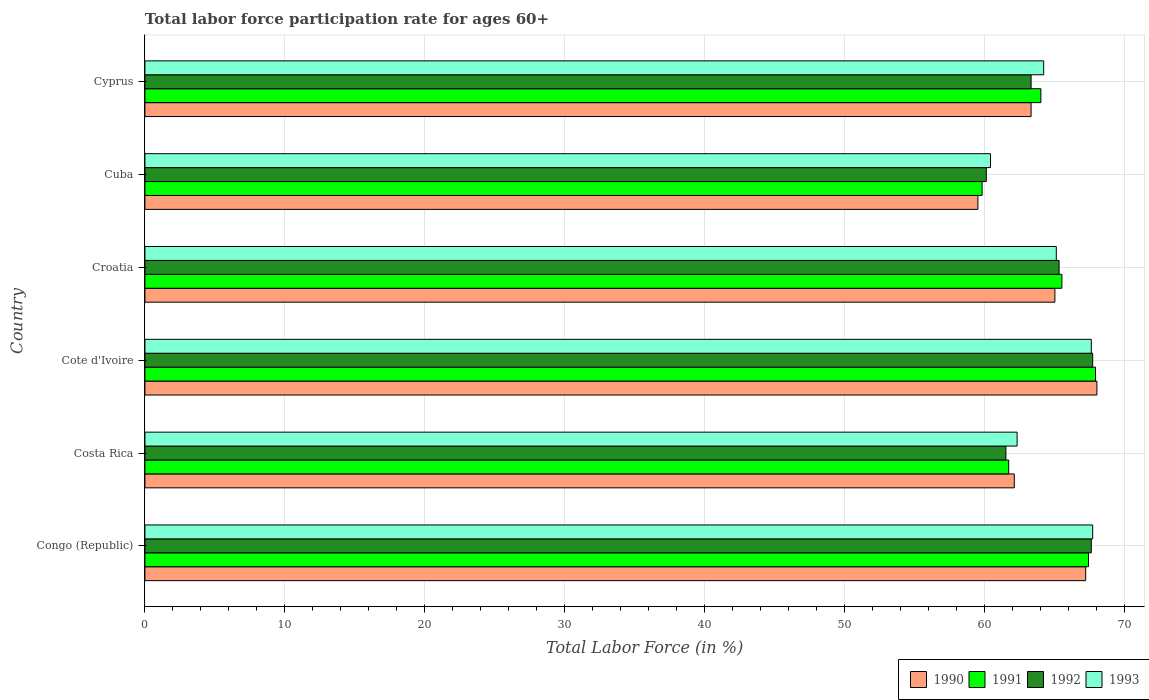How many groups of bars are there?
Your answer should be very brief. 6. Are the number of bars on each tick of the Y-axis equal?
Offer a very short reply. Yes. How many bars are there on the 5th tick from the top?
Provide a succinct answer. 4. How many bars are there on the 6th tick from the bottom?
Provide a short and direct response. 4. What is the label of the 4th group of bars from the top?
Give a very brief answer. Cote d'Ivoire. What is the labor force participation rate in 1993 in Cyprus?
Your response must be concise. 64.2. Across all countries, what is the maximum labor force participation rate in 1992?
Your answer should be compact. 67.7. Across all countries, what is the minimum labor force participation rate in 1990?
Provide a short and direct response. 59.5. In which country was the labor force participation rate in 1991 maximum?
Make the answer very short. Cote d'Ivoire. In which country was the labor force participation rate in 1992 minimum?
Give a very brief answer. Cuba. What is the total labor force participation rate in 1991 in the graph?
Provide a succinct answer. 386.3. What is the difference between the labor force participation rate in 1990 in Costa Rica and that in Cyprus?
Provide a short and direct response. -1.2. What is the difference between the labor force participation rate in 1990 in Croatia and the labor force participation rate in 1992 in Congo (Republic)?
Offer a very short reply. -2.6. What is the average labor force participation rate in 1993 per country?
Ensure brevity in your answer.  64.55. What is the difference between the labor force participation rate in 1991 and labor force participation rate in 1990 in Cuba?
Provide a short and direct response. 0.3. What is the ratio of the labor force participation rate in 1993 in Congo (Republic) to that in Cuba?
Your response must be concise. 1.12. Is the labor force participation rate in 1991 in Congo (Republic) less than that in Cote d'Ivoire?
Offer a very short reply. Yes. What is the difference between the highest and the lowest labor force participation rate in 1992?
Provide a short and direct response. 7.6. What does the 3rd bar from the top in Cote d'Ivoire represents?
Offer a terse response. 1991. Is it the case that in every country, the sum of the labor force participation rate in 1992 and labor force participation rate in 1993 is greater than the labor force participation rate in 1991?
Offer a terse response. Yes. Are all the bars in the graph horizontal?
Give a very brief answer. Yes. What is the difference between two consecutive major ticks on the X-axis?
Make the answer very short. 10. Are the values on the major ticks of X-axis written in scientific E-notation?
Your answer should be compact. No. Does the graph contain grids?
Your answer should be very brief. Yes. Where does the legend appear in the graph?
Your response must be concise. Bottom right. What is the title of the graph?
Make the answer very short. Total labor force participation rate for ages 60+. Does "2012" appear as one of the legend labels in the graph?
Offer a very short reply. No. What is the label or title of the X-axis?
Offer a very short reply. Total Labor Force (in %). What is the label or title of the Y-axis?
Your response must be concise. Country. What is the Total Labor Force (in %) of 1990 in Congo (Republic)?
Keep it short and to the point. 67.2. What is the Total Labor Force (in %) in 1991 in Congo (Republic)?
Make the answer very short. 67.4. What is the Total Labor Force (in %) in 1992 in Congo (Republic)?
Ensure brevity in your answer.  67.6. What is the Total Labor Force (in %) in 1993 in Congo (Republic)?
Offer a very short reply. 67.7. What is the Total Labor Force (in %) of 1990 in Costa Rica?
Your response must be concise. 62.1. What is the Total Labor Force (in %) of 1991 in Costa Rica?
Provide a succinct answer. 61.7. What is the Total Labor Force (in %) of 1992 in Costa Rica?
Keep it short and to the point. 61.5. What is the Total Labor Force (in %) of 1993 in Costa Rica?
Make the answer very short. 62.3. What is the Total Labor Force (in %) in 1990 in Cote d'Ivoire?
Your answer should be very brief. 68. What is the Total Labor Force (in %) in 1991 in Cote d'Ivoire?
Your answer should be very brief. 67.9. What is the Total Labor Force (in %) of 1992 in Cote d'Ivoire?
Your answer should be very brief. 67.7. What is the Total Labor Force (in %) in 1993 in Cote d'Ivoire?
Provide a short and direct response. 67.6. What is the Total Labor Force (in %) of 1990 in Croatia?
Give a very brief answer. 65. What is the Total Labor Force (in %) of 1991 in Croatia?
Your answer should be compact. 65.5. What is the Total Labor Force (in %) in 1992 in Croatia?
Provide a short and direct response. 65.3. What is the Total Labor Force (in %) of 1993 in Croatia?
Offer a very short reply. 65.1. What is the Total Labor Force (in %) in 1990 in Cuba?
Provide a short and direct response. 59.5. What is the Total Labor Force (in %) of 1991 in Cuba?
Offer a terse response. 59.8. What is the Total Labor Force (in %) in 1992 in Cuba?
Provide a succinct answer. 60.1. What is the Total Labor Force (in %) of 1993 in Cuba?
Your response must be concise. 60.4. What is the Total Labor Force (in %) in 1990 in Cyprus?
Offer a very short reply. 63.3. What is the Total Labor Force (in %) of 1992 in Cyprus?
Make the answer very short. 63.3. What is the Total Labor Force (in %) of 1993 in Cyprus?
Provide a short and direct response. 64.2. Across all countries, what is the maximum Total Labor Force (in %) of 1990?
Give a very brief answer. 68. Across all countries, what is the maximum Total Labor Force (in %) in 1991?
Offer a very short reply. 67.9. Across all countries, what is the maximum Total Labor Force (in %) of 1992?
Your answer should be very brief. 67.7. Across all countries, what is the maximum Total Labor Force (in %) of 1993?
Offer a very short reply. 67.7. Across all countries, what is the minimum Total Labor Force (in %) in 1990?
Keep it short and to the point. 59.5. Across all countries, what is the minimum Total Labor Force (in %) in 1991?
Ensure brevity in your answer.  59.8. Across all countries, what is the minimum Total Labor Force (in %) of 1992?
Offer a terse response. 60.1. Across all countries, what is the minimum Total Labor Force (in %) of 1993?
Give a very brief answer. 60.4. What is the total Total Labor Force (in %) of 1990 in the graph?
Provide a short and direct response. 385.1. What is the total Total Labor Force (in %) in 1991 in the graph?
Give a very brief answer. 386.3. What is the total Total Labor Force (in %) in 1992 in the graph?
Provide a short and direct response. 385.5. What is the total Total Labor Force (in %) in 1993 in the graph?
Ensure brevity in your answer.  387.3. What is the difference between the Total Labor Force (in %) of 1992 in Congo (Republic) and that in Costa Rica?
Your answer should be very brief. 6.1. What is the difference between the Total Labor Force (in %) in 1992 in Congo (Republic) and that in Cote d'Ivoire?
Ensure brevity in your answer.  -0.1. What is the difference between the Total Labor Force (in %) of 1993 in Congo (Republic) and that in Cote d'Ivoire?
Your answer should be compact. 0.1. What is the difference between the Total Labor Force (in %) of 1990 in Congo (Republic) and that in Croatia?
Ensure brevity in your answer.  2.2. What is the difference between the Total Labor Force (in %) of 1993 in Congo (Republic) and that in Croatia?
Provide a short and direct response. 2.6. What is the difference between the Total Labor Force (in %) in 1991 in Congo (Republic) and that in Cuba?
Give a very brief answer. 7.6. What is the difference between the Total Labor Force (in %) in 1990 in Congo (Republic) and that in Cyprus?
Ensure brevity in your answer.  3.9. What is the difference between the Total Labor Force (in %) of 1991 in Congo (Republic) and that in Cyprus?
Your answer should be compact. 3.4. What is the difference between the Total Labor Force (in %) in 1992 in Congo (Republic) and that in Cyprus?
Your answer should be very brief. 4.3. What is the difference between the Total Labor Force (in %) in 1991 in Costa Rica and that in Cote d'Ivoire?
Make the answer very short. -6.2. What is the difference between the Total Labor Force (in %) of 1990 in Costa Rica and that in Croatia?
Your response must be concise. -2.9. What is the difference between the Total Labor Force (in %) of 1991 in Costa Rica and that in Croatia?
Make the answer very short. -3.8. What is the difference between the Total Labor Force (in %) in 1992 in Costa Rica and that in Croatia?
Your answer should be compact. -3.8. What is the difference between the Total Labor Force (in %) in 1990 in Costa Rica and that in Cuba?
Offer a very short reply. 2.6. What is the difference between the Total Labor Force (in %) of 1991 in Costa Rica and that in Cuba?
Offer a terse response. 1.9. What is the difference between the Total Labor Force (in %) of 1990 in Costa Rica and that in Cyprus?
Provide a succinct answer. -1.2. What is the difference between the Total Labor Force (in %) in 1991 in Costa Rica and that in Cyprus?
Your answer should be very brief. -2.3. What is the difference between the Total Labor Force (in %) in 1992 in Costa Rica and that in Cyprus?
Provide a succinct answer. -1.8. What is the difference between the Total Labor Force (in %) of 1993 in Costa Rica and that in Cyprus?
Provide a succinct answer. -1.9. What is the difference between the Total Labor Force (in %) in 1991 in Cote d'Ivoire and that in Croatia?
Your answer should be very brief. 2.4. What is the difference between the Total Labor Force (in %) of 1993 in Cote d'Ivoire and that in Croatia?
Your answer should be very brief. 2.5. What is the difference between the Total Labor Force (in %) of 1990 in Cote d'Ivoire and that in Cuba?
Your answer should be compact. 8.5. What is the difference between the Total Labor Force (in %) of 1991 in Cote d'Ivoire and that in Cuba?
Make the answer very short. 8.1. What is the difference between the Total Labor Force (in %) in 1992 in Cote d'Ivoire and that in Cuba?
Give a very brief answer. 7.6. What is the difference between the Total Labor Force (in %) in 1990 in Cote d'Ivoire and that in Cyprus?
Offer a terse response. 4.7. What is the difference between the Total Labor Force (in %) of 1991 in Cote d'Ivoire and that in Cyprus?
Offer a terse response. 3.9. What is the difference between the Total Labor Force (in %) in 1993 in Cote d'Ivoire and that in Cyprus?
Keep it short and to the point. 3.4. What is the difference between the Total Labor Force (in %) of 1990 in Croatia and that in Cuba?
Your answer should be compact. 5.5. What is the difference between the Total Labor Force (in %) of 1992 in Croatia and that in Cuba?
Offer a terse response. 5.2. What is the difference between the Total Labor Force (in %) in 1990 in Croatia and that in Cyprus?
Your answer should be very brief. 1.7. What is the difference between the Total Labor Force (in %) in 1990 in Cuba and that in Cyprus?
Your answer should be very brief. -3.8. What is the difference between the Total Labor Force (in %) in 1991 in Cuba and that in Cyprus?
Your response must be concise. -4.2. What is the difference between the Total Labor Force (in %) of 1992 in Cuba and that in Cyprus?
Provide a short and direct response. -3.2. What is the difference between the Total Labor Force (in %) of 1993 in Cuba and that in Cyprus?
Your answer should be compact. -3.8. What is the difference between the Total Labor Force (in %) in 1990 in Congo (Republic) and the Total Labor Force (in %) in 1991 in Costa Rica?
Give a very brief answer. 5.5. What is the difference between the Total Labor Force (in %) in 1990 in Congo (Republic) and the Total Labor Force (in %) in 1992 in Costa Rica?
Ensure brevity in your answer.  5.7. What is the difference between the Total Labor Force (in %) in 1991 in Congo (Republic) and the Total Labor Force (in %) in 1993 in Costa Rica?
Ensure brevity in your answer.  5.1. What is the difference between the Total Labor Force (in %) of 1992 in Congo (Republic) and the Total Labor Force (in %) of 1993 in Costa Rica?
Your response must be concise. 5.3. What is the difference between the Total Labor Force (in %) in 1990 in Congo (Republic) and the Total Labor Force (in %) in 1993 in Cote d'Ivoire?
Your response must be concise. -0.4. What is the difference between the Total Labor Force (in %) of 1991 in Congo (Republic) and the Total Labor Force (in %) of 1993 in Cote d'Ivoire?
Your answer should be compact. -0.2. What is the difference between the Total Labor Force (in %) of 1992 in Congo (Republic) and the Total Labor Force (in %) of 1993 in Cote d'Ivoire?
Ensure brevity in your answer.  0. What is the difference between the Total Labor Force (in %) of 1990 in Congo (Republic) and the Total Labor Force (in %) of 1992 in Croatia?
Make the answer very short. 1.9. What is the difference between the Total Labor Force (in %) in 1991 in Congo (Republic) and the Total Labor Force (in %) in 1993 in Croatia?
Your response must be concise. 2.3. What is the difference between the Total Labor Force (in %) in 1992 in Congo (Republic) and the Total Labor Force (in %) in 1993 in Croatia?
Provide a short and direct response. 2.5. What is the difference between the Total Labor Force (in %) of 1990 in Congo (Republic) and the Total Labor Force (in %) of 1991 in Cuba?
Provide a short and direct response. 7.4. What is the difference between the Total Labor Force (in %) in 1990 in Congo (Republic) and the Total Labor Force (in %) in 1993 in Cuba?
Your response must be concise. 6.8. What is the difference between the Total Labor Force (in %) in 1990 in Congo (Republic) and the Total Labor Force (in %) in 1991 in Cyprus?
Your answer should be very brief. 3.2. What is the difference between the Total Labor Force (in %) of 1992 in Congo (Republic) and the Total Labor Force (in %) of 1993 in Cyprus?
Your response must be concise. 3.4. What is the difference between the Total Labor Force (in %) in 1990 in Costa Rica and the Total Labor Force (in %) in 1993 in Cote d'Ivoire?
Your answer should be very brief. -5.5. What is the difference between the Total Labor Force (in %) of 1991 in Costa Rica and the Total Labor Force (in %) of 1992 in Cote d'Ivoire?
Give a very brief answer. -6. What is the difference between the Total Labor Force (in %) of 1991 in Costa Rica and the Total Labor Force (in %) of 1993 in Cote d'Ivoire?
Provide a succinct answer. -5.9. What is the difference between the Total Labor Force (in %) of 1990 in Costa Rica and the Total Labor Force (in %) of 1993 in Croatia?
Offer a terse response. -3. What is the difference between the Total Labor Force (in %) in 1991 in Costa Rica and the Total Labor Force (in %) in 1992 in Croatia?
Provide a short and direct response. -3.6. What is the difference between the Total Labor Force (in %) of 1992 in Costa Rica and the Total Labor Force (in %) of 1993 in Croatia?
Offer a very short reply. -3.6. What is the difference between the Total Labor Force (in %) of 1990 in Costa Rica and the Total Labor Force (in %) of 1992 in Cuba?
Provide a succinct answer. 2. What is the difference between the Total Labor Force (in %) of 1990 in Costa Rica and the Total Labor Force (in %) of 1993 in Cuba?
Keep it short and to the point. 1.7. What is the difference between the Total Labor Force (in %) in 1991 in Costa Rica and the Total Labor Force (in %) in 1992 in Cuba?
Offer a very short reply. 1.6. What is the difference between the Total Labor Force (in %) in 1991 in Costa Rica and the Total Labor Force (in %) in 1993 in Cuba?
Your response must be concise. 1.3. What is the difference between the Total Labor Force (in %) in 1990 in Costa Rica and the Total Labor Force (in %) in 1993 in Cyprus?
Offer a terse response. -2.1. What is the difference between the Total Labor Force (in %) in 1991 in Cote d'Ivoire and the Total Labor Force (in %) in 1992 in Croatia?
Ensure brevity in your answer.  2.6. What is the difference between the Total Labor Force (in %) in 1990 in Cote d'Ivoire and the Total Labor Force (in %) in 1991 in Cuba?
Offer a very short reply. 8.2. What is the difference between the Total Labor Force (in %) of 1990 in Cote d'Ivoire and the Total Labor Force (in %) of 1992 in Cuba?
Give a very brief answer. 7.9. What is the difference between the Total Labor Force (in %) of 1991 in Cote d'Ivoire and the Total Labor Force (in %) of 1992 in Cuba?
Keep it short and to the point. 7.8. What is the difference between the Total Labor Force (in %) in 1990 in Cote d'Ivoire and the Total Labor Force (in %) in 1991 in Cyprus?
Your answer should be compact. 4. What is the difference between the Total Labor Force (in %) of 1990 in Cote d'Ivoire and the Total Labor Force (in %) of 1993 in Cyprus?
Your answer should be compact. 3.8. What is the difference between the Total Labor Force (in %) in 1991 in Cote d'Ivoire and the Total Labor Force (in %) in 1993 in Cyprus?
Provide a succinct answer. 3.7. What is the difference between the Total Labor Force (in %) in 1992 in Cote d'Ivoire and the Total Labor Force (in %) in 1993 in Cyprus?
Give a very brief answer. 3.5. What is the difference between the Total Labor Force (in %) of 1990 in Croatia and the Total Labor Force (in %) of 1991 in Cuba?
Offer a terse response. 5.2. What is the difference between the Total Labor Force (in %) in 1990 in Croatia and the Total Labor Force (in %) in 1993 in Cuba?
Your response must be concise. 4.6. What is the difference between the Total Labor Force (in %) in 1991 in Croatia and the Total Labor Force (in %) in 1992 in Cuba?
Offer a very short reply. 5.4. What is the difference between the Total Labor Force (in %) in 1992 in Croatia and the Total Labor Force (in %) in 1993 in Cuba?
Ensure brevity in your answer.  4.9. What is the difference between the Total Labor Force (in %) in 1990 in Croatia and the Total Labor Force (in %) in 1991 in Cyprus?
Your response must be concise. 1. What is the difference between the Total Labor Force (in %) in 1990 in Croatia and the Total Labor Force (in %) in 1993 in Cyprus?
Your answer should be compact. 0.8. What is the difference between the Total Labor Force (in %) of 1992 in Croatia and the Total Labor Force (in %) of 1993 in Cyprus?
Ensure brevity in your answer.  1.1. What is the difference between the Total Labor Force (in %) of 1990 in Cuba and the Total Labor Force (in %) of 1991 in Cyprus?
Offer a terse response. -4.5. What is the average Total Labor Force (in %) in 1990 per country?
Offer a very short reply. 64.18. What is the average Total Labor Force (in %) in 1991 per country?
Keep it short and to the point. 64.38. What is the average Total Labor Force (in %) in 1992 per country?
Offer a very short reply. 64.25. What is the average Total Labor Force (in %) in 1993 per country?
Ensure brevity in your answer.  64.55. What is the difference between the Total Labor Force (in %) of 1990 and Total Labor Force (in %) of 1991 in Congo (Republic)?
Ensure brevity in your answer.  -0.2. What is the difference between the Total Labor Force (in %) of 1990 and Total Labor Force (in %) of 1992 in Congo (Republic)?
Your answer should be very brief. -0.4. What is the difference between the Total Labor Force (in %) in 1991 and Total Labor Force (in %) in 1992 in Congo (Republic)?
Your response must be concise. -0.2. What is the difference between the Total Labor Force (in %) in 1991 and Total Labor Force (in %) in 1992 in Costa Rica?
Offer a terse response. 0.2. What is the difference between the Total Labor Force (in %) of 1991 and Total Labor Force (in %) of 1993 in Costa Rica?
Give a very brief answer. -0.6. What is the difference between the Total Labor Force (in %) of 1992 and Total Labor Force (in %) of 1993 in Costa Rica?
Your answer should be compact. -0.8. What is the difference between the Total Labor Force (in %) in 1990 and Total Labor Force (in %) in 1991 in Cote d'Ivoire?
Provide a succinct answer. 0.1. What is the difference between the Total Labor Force (in %) of 1990 and Total Labor Force (in %) of 1992 in Cote d'Ivoire?
Ensure brevity in your answer.  0.3. What is the difference between the Total Labor Force (in %) of 1990 and Total Labor Force (in %) of 1993 in Cote d'Ivoire?
Your answer should be very brief. 0.4. What is the difference between the Total Labor Force (in %) in 1990 and Total Labor Force (in %) in 1992 in Croatia?
Your answer should be very brief. -0.3. What is the difference between the Total Labor Force (in %) of 1990 and Total Labor Force (in %) of 1993 in Croatia?
Your answer should be very brief. -0.1. What is the difference between the Total Labor Force (in %) of 1991 and Total Labor Force (in %) of 1993 in Croatia?
Your response must be concise. 0.4. What is the difference between the Total Labor Force (in %) of 1990 and Total Labor Force (in %) of 1992 in Cuba?
Your answer should be compact. -0.6. What is the difference between the Total Labor Force (in %) of 1990 and Total Labor Force (in %) of 1993 in Cuba?
Ensure brevity in your answer.  -0.9. What is the difference between the Total Labor Force (in %) in 1991 and Total Labor Force (in %) in 1993 in Cuba?
Make the answer very short. -0.6. What is the difference between the Total Labor Force (in %) in 1990 and Total Labor Force (in %) in 1991 in Cyprus?
Ensure brevity in your answer.  -0.7. What is the difference between the Total Labor Force (in %) of 1991 and Total Labor Force (in %) of 1992 in Cyprus?
Your answer should be very brief. 0.7. What is the difference between the Total Labor Force (in %) of 1992 and Total Labor Force (in %) of 1993 in Cyprus?
Make the answer very short. -0.9. What is the ratio of the Total Labor Force (in %) of 1990 in Congo (Republic) to that in Costa Rica?
Offer a very short reply. 1.08. What is the ratio of the Total Labor Force (in %) in 1991 in Congo (Republic) to that in Costa Rica?
Provide a succinct answer. 1.09. What is the ratio of the Total Labor Force (in %) in 1992 in Congo (Republic) to that in Costa Rica?
Offer a terse response. 1.1. What is the ratio of the Total Labor Force (in %) in 1993 in Congo (Republic) to that in Costa Rica?
Ensure brevity in your answer.  1.09. What is the ratio of the Total Labor Force (in %) in 1992 in Congo (Republic) to that in Cote d'Ivoire?
Ensure brevity in your answer.  1. What is the ratio of the Total Labor Force (in %) of 1990 in Congo (Republic) to that in Croatia?
Make the answer very short. 1.03. What is the ratio of the Total Labor Force (in %) of 1991 in Congo (Republic) to that in Croatia?
Provide a short and direct response. 1.03. What is the ratio of the Total Labor Force (in %) of 1992 in Congo (Republic) to that in Croatia?
Provide a succinct answer. 1.04. What is the ratio of the Total Labor Force (in %) of 1993 in Congo (Republic) to that in Croatia?
Ensure brevity in your answer.  1.04. What is the ratio of the Total Labor Force (in %) of 1990 in Congo (Republic) to that in Cuba?
Your response must be concise. 1.13. What is the ratio of the Total Labor Force (in %) in 1991 in Congo (Republic) to that in Cuba?
Provide a succinct answer. 1.13. What is the ratio of the Total Labor Force (in %) of 1992 in Congo (Republic) to that in Cuba?
Offer a terse response. 1.12. What is the ratio of the Total Labor Force (in %) of 1993 in Congo (Republic) to that in Cuba?
Ensure brevity in your answer.  1.12. What is the ratio of the Total Labor Force (in %) in 1990 in Congo (Republic) to that in Cyprus?
Give a very brief answer. 1.06. What is the ratio of the Total Labor Force (in %) in 1991 in Congo (Republic) to that in Cyprus?
Offer a very short reply. 1.05. What is the ratio of the Total Labor Force (in %) of 1992 in Congo (Republic) to that in Cyprus?
Offer a terse response. 1.07. What is the ratio of the Total Labor Force (in %) of 1993 in Congo (Republic) to that in Cyprus?
Your answer should be very brief. 1.05. What is the ratio of the Total Labor Force (in %) of 1990 in Costa Rica to that in Cote d'Ivoire?
Ensure brevity in your answer.  0.91. What is the ratio of the Total Labor Force (in %) of 1991 in Costa Rica to that in Cote d'Ivoire?
Your response must be concise. 0.91. What is the ratio of the Total Labor Force (in %) of 1992 in Costa Rica to that in Cote d'Ivoire?
Offer a terse response. 0.91. What is the ratio of the Total Labor Force (in %) of 1993 in Costa Rica to that in Cote d'Ivoire?
Offer a very short reply. 0.92. What is the ratio of the Total Labor Force (in %) in 1990 in Costa Rica to that in Croatia?
Ensure brevity in your answer.  0.96. What is the ratio of the Total Labor Force (in %) in 1991 in Costa Rica to that in Croatia?
Ensure brevity in your answer.  0.94. What is the ratio of the Total Labor Force (in %) of 1992 in Costa Rica to that in Croatia?
Make the answer very short. 0.94. What is the ratio of the Total Labor Force (in %) of 1990 in Costa Rica to that in Cuba?
Offer a terse response. 1.04. What is the ratio of the Total Labor Force (in %) in 1991 in Costa Rica to that in Cuba?
Your answer should be very brief. 1.03. What is the ratio of the Total Labor Force (in %) in 1992 in Costa Rica to that in Cuba?
Your answer should be compact. 1.02. What is the ratio of the Total Labor Force (in %) in 1993 in Costa Rica to that in Cuba?
Your answer should be very brief. 1.03. What is the ratio of the Total Labor Force (in %) in 1991 in Costa Rica to that in Cyprus?
Provide a short and direct response. 0.96. What is the ratio of the Total Labor Force (in %) of 1992 in Costa Rica to that in Cyprus?
Make the answer very short. 0.97. What is the ratio of the Total Labor Force (in %) in 1993 in Costa Rica to that in Cyprus?
Ensure brevity in your answer.  0.97. What is the ratio of the Total Labor Force (in %) in 1990 in Cote d'Ivoire to that in Croatia?
Give a very brief answer. 1.05. What is the ratio of the Total Labor Force (in %) in 1991 in Cote d'Ivoire to that in Croatia?
Offer a very short reply. 1.04. What is the ratio of the Total Labor Force (in %) in 1992 in Cote d'Ivoire to that in Croatia?
Keep it short and to the point. 1.04. What is the ratio of the Total Labor Force (in %) of 1993 in Cote d'Ivoire to that in Croatia?
Your response must be concise. 1.04. What is the ratio of the Total Labor Force (in %) in 1991 in Cote d'Ivoire to that in Cuba?
Provide a short and direct response. 1.14. What is the ratio of the Total Labor Force (in %) of 1992 in Cote d'Ivoire to that in Cuba?
Ensure brevity in your answer.  1.13. What is the ratio of the Total Labor Force (in %) in 1993 in Cote d'Ivoire to that in Cuba?
Give a very brief answer. 1.12. What is the ratio of the Total Labor Force (in %) in 1990 in Cote d'Ivoire to that in Cyprus?
Offer a terse response. 1.07. What is the ratio of the Total Labor Force (in %) of 1991 in Cote d'Ivoire to that in Cyprus?
Your answer should be very brief. 1.06. What is the ratio of the Total Labor Force (in %) in 1992 in Cote d'Ivoire to that in Cyprus?
Provide a short and direct response. 1.07. What is the ratio of the Total Labor Force (in %) of 1993 in Cote d'Ivoire to that in Cyprus?
Keep it short and to the point. 1.05. What is the ratio of the Total Labor Force (in %) of 1990 in Croatia to that in Cuba?
Offer a very short reply. 1.09. What is the ratio of the Total Labor Force (in %) of 1991 in Croatia to that in Cuba?
Your response must be concise. 1.1. What is the ratio of the Total Labor Force (in %) of 1992 in Croatia to that in Cuba?
Ensure brevity in your answer.  1.09. What is the ratio of the Total Labor Force (in %) of 1993 in Croatia to that in Cuba?
Give a very brief answer. 1.08. What is the ratio of the Total Labor Force (in %) in 1990 in Croatia to that in Cyprus?
Offer a terse response. 1.03. What is the ratio of the Total Labor Force (in %) in 1991 in Croatia to that in Cyprus?
Keep it short and to the point. 1.02. What is the ratio of the Total Labor Force (in %) of 1992 in Croatia to that in Cyprus?
Offer a very short reply. 1.03. What is the ratio of the Total Labor Force (in %) in 1993 in Croatia to that in Cyprus?
Provide a short and direct response. 1.01. What is the ratio of the Total Labor Force (in %) of 1990 in Cuba to that in Cyprus?
Provide a short and direct response. 0.94. What is the ratio of the Total Labor Force (in %) of 1991 in Cuba to that in Cyprus?
Provide a succinct answer. 0.93. What is the ratio of the Total Labor Force (in %) in 1992 in Cuba to that in Cyprus?
Your response must be concise. 0.95. What is the ratio of the Total Labor Force (in %) of 1993 in Cuba to that in Cyprus?
Keep it short and to the point. 0.94. What is the difference between the highest and the second highest Total Labor Force (in %) in 1990?
Provide a short and direct response. 0.8. What is the difference between the highest and the second highest Total Labor Force (in %) in 1991?
Ensure brevity in your answer.  0.5. What is the difference between the highest and the second highest Total Labor Force (in %) of 1992?
Offer a terse response. 0.1. What is the difference between the highest and the second highest Total Labor Force (in %) in 1993?
Your answer should be very brief. 0.1. What is the difference between the highest and the lowest Total Labor Force (in %) of 1990?
Make the answer very short. 8.5. What is the difference between the highest and the lowest Total Labor Force (in %) of 1993?
Your response must be concise. 7.3. 